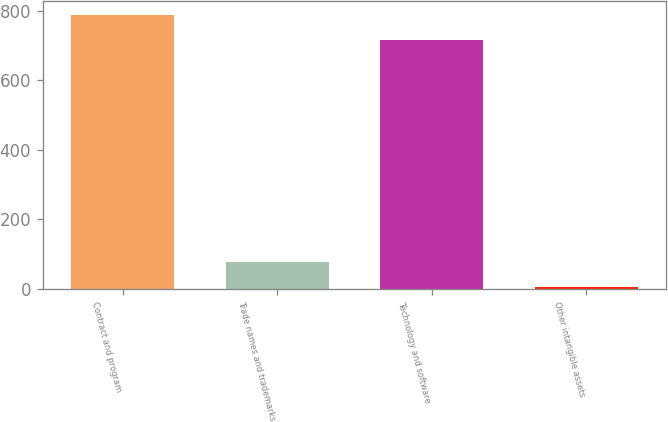Convert chart to OTSL. <chart><loc_0><loc_0><loc_500><loc_500><bar_chart><fcel>Contract and program<fcel>Trade names and trademarks<fcel>Technology and software<fcel>Other intangible assets<nl><fcel>787.5<fcel>77.5<fcel>715<fcel>5<nl></chart> 